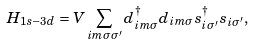Convert formula to latex. <formula><loc_0><loc_0><loc_500><loc_500>H _ { 1 s - 3 d } = V \sum _ { i m \sigma \sigma ^ { \prime } } d _ { i m \sigma } ^ { \dagger } d _ { i m \sigma } s _ { i \sigma ^ { \prime } } ^ { \dagger } s _ { i \sigma ^ { \prime } } ,</formula> 